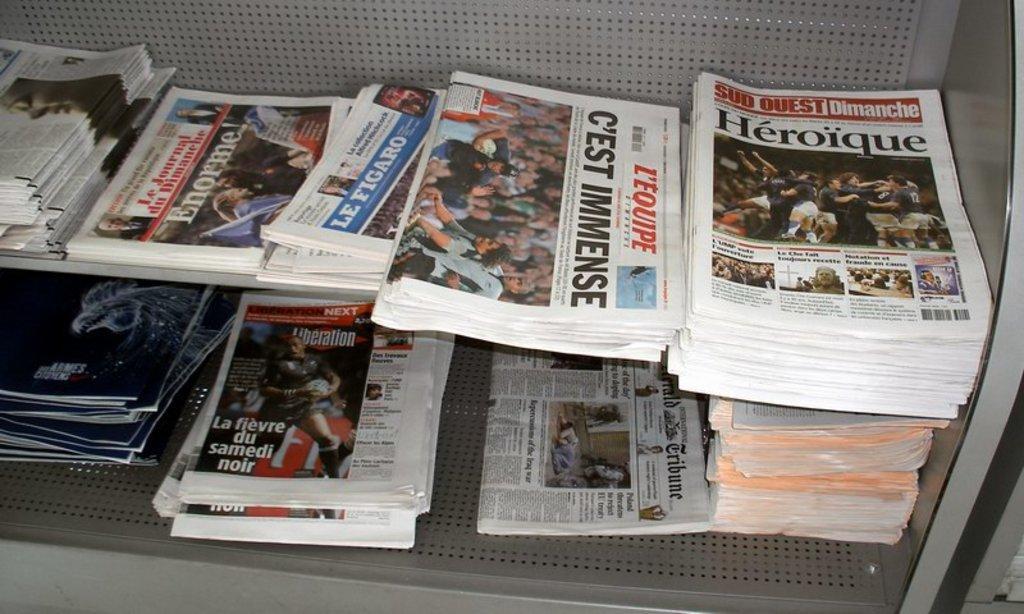In one or two sentences, can you explain what this image depicts? Here in this picture we can see a shelf present on the floor and in that we can see number of news papers and magazines present and we can also see number of pictures on the papers. 